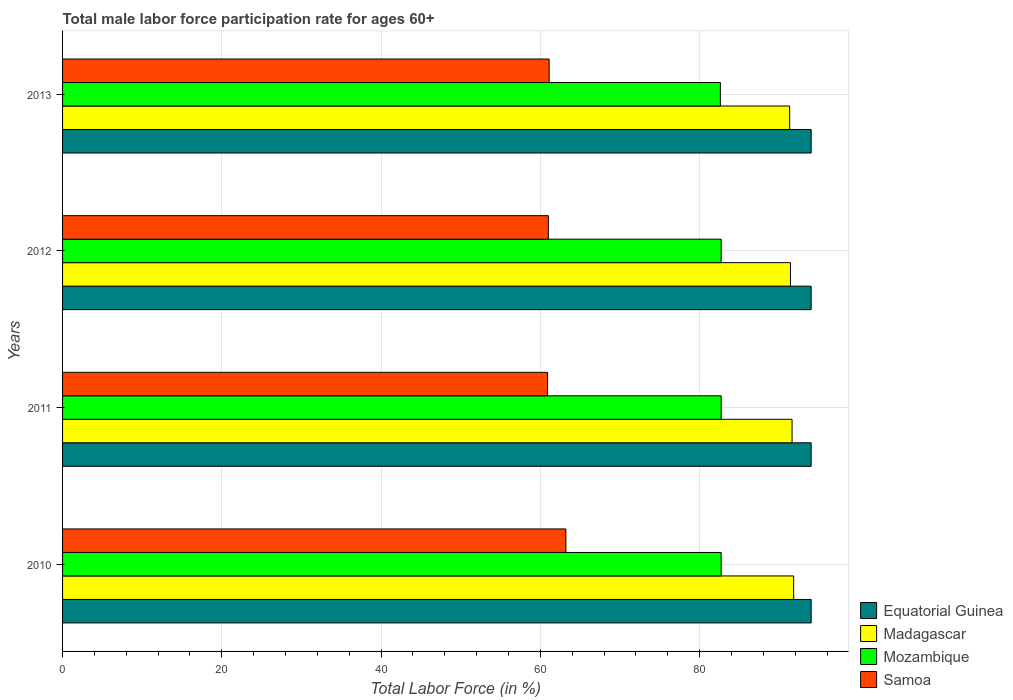How many groups of bars are there?
Make the answer very short. 4. Are the number of bars per tick equal to the number of legend labels?
Your response must be concise. Yes. Are the number of bars on each tick of the Y-axis equal?
Your response must be concise. Yes. How many bars are there on the 3rd tick from the top?
Provide a short and direct response. 4. How many bars are there on the 4th tick from the bottom?
Your response must be concise. 4. In how many cases, is the number of bars for a given year not equal to the number of legend labels?
Give a very brief answer. 0. What is the male labor force participation rate in Mozambique in 2013?
Offer a terse response. 82.6. Across all years, what is the maximum male labor force participation rate in Mozambique?
Offer a very short reply. 82.7. Across all years, what is the minimum male labor force participation rate in Madagascar?
Your response must be concise. 91.3. In which year was the male labor force participation rate in Mozambique maximum?
Offer a terse response. 2010. What is the total male labor force participation rate in Samoa in the graph?
Offer a very short reply. 246.2. What is the difference between the male labor force participation rate in Madagascar in 2011 and the male labor force participation rate in Samoa in 2013?
Your response must be concise. 30.5. What is the average male labor force participation rate in Madagascar per year?
Your answer should be very brief. 91.53. In the year 2013, what is the difference between the male labor force participation rate in Mozambique and male labor force participation rate in Equatorial Guinea?
Give a very brief answer. -11.4. What is the ratio of the male labor force participation rate in Mozambique in 2012 to that in 2013?
Provide a succinct answer. 1. What is the difference between the highest and the second highest male labor force participation rate in Mozambique?
Ensure brevity in your answer.  0. What is the difference between the highest and the lowest male labor force participation rate in Samoa?
Provide a short and direct response. 2.3. Is it the case that in every year, the sum of the male labor force participation rate in Equatorial Guinea and male labor force participation rate in Madagascar is greater than the sum of male labor force participation rate in Mozambique and male labor force participation rate in Samoa?
Provide a succinct answer. No. What does the 3rd bar from the top in 2013 represents?
Keep it short and to the point. Madagascar. What does the 2nd bar from the bottom in 2011 represents?
Provide a succinct answer. Madagascar. Is it the case that in every year, the sum of the male labor force participation rate in Madagascar and male labor force participation rate in Samoa is greater than the male labor force participation rate in Mozambique?
Offer a very short reply. Yes. How many bars are there?
Provide a succinct answer. 16. Are all the bars in the graph horizontal?
Ensure brevity in your answer.  Yes. How many years are there in the graph?
Make the answer very short. 4. Are the values on the major ticks of X-axis written in scientific E-notation?
Provide a succinct answer. No. Does the graph contain any zero values?
Provide a succinct answer. No. Where does the legend appear in the graph?
Make the answer very short. Bottom right. How are the legend labels stacked?
Provide a short and direct response. Vertical. What is the title of the graph?
Your response must be concise. Total male labor force participation rate for ages 60+. Does "High income: nonOECD" appear as one of the legend labels in the graph?
Your answer should be very brief. No. What is the label or title of the X-axis?
Keep it short and to the point. Total Labor Force (in %). What is the Total Labor Force (in %) in Equatorial Guinea in 2010?
Offer a terse response. 94. What is the Total Labor Force (in %) in Madagascar in 2010?
Make the answer very short. 91.8. What is the Total Labor Force (in %) in Mozambique in 2010?
Your answer should be compact. 82.7. What is the Total Labor Force (in %) of Samoa in 2010?
Offer a very short reply. 63.2. What is the Total Labor Force (in %) of Equatorial Guinea in 2011?
Your answer should be very brief. 94. What is the Total Labor Force (in %) of Madagascar in 2011?
Provide a short and direct response. 91.6. What is the Total Labor Force (in %) of Mozambique in 2011?
Give a very brief answer. 82.7. What is the Total Labor Force (in %) in Samoa in 2011?
Offer a terse response. 60.9. What is the Total Labor Force (in %) of Equatorial Guinea in 2012?
Provide a succinct answer. 94. What is the Total Labor Force (in %) in Madagascar in 2012?
Offer a very short reply. 91.4. What is the Total Labor Force (in %) of Mozambique in 2012?
Keep it short and to the point. 82.7. What is the Total Labor Force (in %) in Equatorial Guinea in 2013?
Give a very brief answer. 94. What is the Total Labor Force (in %) in Madagascar in 2013?
Your answer should be very brief. 91.3. What is the Total Labor Force (in %) in Mozambique in 2013?
Offer a very short reply. 82.6. What is the Total Labor Force (in %) in Samoa in 2013?
Provide a short and direct response. 61.1. Across all years, what is the maximum Total Labor Force (in %) in Equatorial Guinea?
Provide a succinct answer. 94. Across all years, what is the maximum Total Labor Force (in %) of Madagascar?
Your answer should be very brief. 91.8. Across all years, what is the maximum Total Labor Force (in %) of Mozambique?
Provide a short and direct response. 82.7. Across all years, what is the maximum Total Labor Force (in %) in Samoa?
Provide a short and direct response. 63.2. Across all years, what is the minimum Total Labor Force (in %) in Equatorial Guinea?
Your response must be concise. 94. Across all years, what is the minimum Total Labor Force (in %) in Madagascar?
Offer a very short reply. 91.3. Across all years, what is the minimum Total Labor Force (in %) of Mozambique?
Your response must be concise. 82.6. Across all years, what is the minimum Total Labor Force (in %) in Samoa?
Offer a terse response. 60.9. What is the total Total Labor Force (in %) in Equatorial Guinea in the graph?
Make the answer very short. 376. What is the total Total Labor Force (in %) of Madagascar in the graph?
Offer a terse response. 366.1. What is the total Total Labor Force (in %) of Mozambique in the graph?
Provide a short and direct response. 330.7. What is the total Total Labor Force (in %) of Samoa in the graph?
Provide a succinct answer. 246.2. What is the difference between the Total Labor Force (in %) in Equatorial Guinea in 2010 and that in 2011?
Provide a short and direct response. 0. What is the difference between the Total Labor Force (in %) in Madagascar in 2010 and that in 2011?
Your response must be concise. 0.2. What is the difference between the Total Labor Force (in %) in Mozambique in 2010 and that in 2011?
Your response must be concise. 0. What is the difference between the Total Labor Force (in %) of Samoa in 2010 and that in 2011?
Your answer should be compact. 2.3. What is the difference between the Total Labor Force (in %) of Equatorial Guinea in 2010 and that in 2012?
Your response must be concise. 0. What is the difference between the Total Labor Force (in %) in Mozambique in 2010 and that in 2012?
Make the answer very short. 0. What is the difference between the Total Labor Force (in %) in Samoa in 2010 and that in 2012?
Give a very brief answer. 2.2. What is the difference between the Total Labor Force (in %) of Madagascar in 2010 and that in 2013?
Offer a terse response. 0.5. What is the difference between the Total Labor Force (in %) in Samoa in 2010 and that in 2013?
Provide a succinct answer. 2.1. What is the difference between the Total Labor Force (in %) of Samoa in 2011 and that in 2012?
Your answer should be compact. -0.1. What is the difference between the Total Labor Force (in %) of Equatorial Guinea in 2011 and that in 2013?
Give a very brief answer. 0. What is the difference between the Total Labor Force (in %) in Mozambique in 2011 and that in 2013?
Give a very brief answer. 0.1. What is the difference between the Total Labor Force (in %) of Madagascar in 2012 and that in 2013?
Make the answer very short. 0.1. What is the difference between the Total Labor Force (in %) of Mozambique in 2012 and that in 2013?
Make the answer very short. 0.1. What is the difference between the Total Labor Force (in %) in Samoa in 2012 and that in 2013?
Your response must be concise. -0.1. What is the difference between the Total Labor Force (in %) of Equatorial Guinea in 2010 and the Total Labor Force (in %) of Madagascar in 2011?
Keep it short and to the point. 2.4. What is the difference between the Total Labor Force (in %) in Equatorial Guinea in 2010 and the Total Labor Force (in %) in Samoa in 2011?
Provide a succinct answer. 33.1. What is the difference between the Total Labor Force (in %) in Madagascar in 2010 and the Total Labor Force (in %) in Mozambique in 2011?
Ensure brevity in your answer.  9.1. What is the difference between the Total Labor Force (in %) of Madagascar in 2010 and the Total Labor Force (in %) of Samoa in 2011?
Give a very brief answer. 30.9. What is the difference between the Total Labor Force (in %) of Mozambique in 2010 and the Total Labor Force (in %) of Samoa in 2011?
Your answer should be compact. 21.8. What is the difference between the Total Labor Force (in %) of Equatorial Guinea in 2010 and the Total Labor Force (in %) of Mozambique in 2012?
Provide a short and direct response. 11.3. What is the difference between the Total Labor Force (in %) in Madagascar in 2010 and the Total Labor Force (in %) in Samoa in 2012?
Offer a terse response. 30.8. What is the difference between the Total Labor Force (in %) in Mozambique in 2010 and the Total Labor Force (in %) in Samoa in 2012?
Your response must be concise. 21.7. What is the difference between the Total Labor Force (in %) of Equatorial Guinea in 2010 and the Total Labor Force (in %) of Mozambique in 2013?
Provide a short and direct response. 11.4. What is the difference between the Total Labor Force (in %) of Equatorial Guinea in 2010 and the Total Labor Force (in %) of Samoa in 2013?
Give a very brief answer. 32.9. What is the difference between the Total Labor Force (in %) in Madagascar in 2010 and the Total Labor Force (in %) in Mozambique in 2013?
Your answer should be compact. 9.2. What is the difference between the Total Labor Force (in %) of Madagascar in 2010 and the Total Labor Force (in %) of Samoa in 2013?
Your answer should be compact. 30.7. What is the difference between the Total Labor Force (in %) in Mozambique in 2010 and the Total Labor Force (in %) in Samoa in 2013?
Offer a very short reply. 21.6. What is the difference between the Total Labor Force (in %) in Equatorial Guinea in 2011 and the Total Labor Force (in %) in Mozambique in 2012?
Your answer should be compact. 11.3. What is the difference between the Total Labor Force (in %) of Madagascar in 2011 and the Total Labor Force (in %) of Samoa in 2012?
Provide a short and direct response. 30.6. What is the difference between the Total Labor Force (in %) in Mozambique in 2011 and the Total Labor Force (in %) in Samoa in 2012?
Make the answer very short. 21.7. What is the difference between the Total Labor Force (in %) of Equatorial Guinea in 2011 and the Total Labor Force (in %) of Madagascar in 2013?
Ensure brevity in your answer.  2.7. What is the difference between the Total Labor Force (in %) in Equatorial Guinea in 2011 and the Total Labor Force (in %) in Mozambique in 2013?
Your answer should be very brief. 11.4. What is the difference between the Total Labor Force (in %) of Equatorial Guinea in 2011 and the Total Labor Force (in %) of Samoa in 2013?
Your response must be concise. 32.9. What is the difference between the Total Labor Force (in %) in Madagascar in 2011 and the Total Labor Force (in %) in Mozambique in 2013?
Provide a short and direct response. 9. What is the difference between the Total Labor Force (in %) of Madagascar in 2011 and the Total Labor Force (in %) of Samoa in 2013?
Offer a terse response. 30.5. What is the difference between the Total Labor Force (in %) in Mozambique in 2011 and the Total Labor Force (in %) in Samoa in 2013?
Your answer should be very brief. 21.6. What is the difference between the Total Labor Force (in %) in Equatorial Guinea in 2012 and the Total Labor Force (in %) in Madagascar in 2013?
Give a very brief answer. 2.7. What is the difference between the Total Labor Force (in %) of Equatorial Guinea in 2012 and the Total Labor Force (in %) of Samoa in 2013?
Keep it short and to the point. 32.9. What is the difference between the Total Labor Force (in %) of Madagascar in 2012 and the Total Labor Force (in %) of Samoa in 2013?
Your response must be concise. 30.3. What is the difference between the Total Labor Force (in %) in Mozambique in 2012 and the Total Labor Force (in %) in Samoa in 2013?
Your answer should be very brief. 21.6. What is the average Total Labor Force (in %) of Equatorial Guinea per year?
Your answer should be compact. 94. What is the average Total Labor Force (in %) in Madagascar per year?
Provide a succinct answer. 91.53. What is the average Total Labor Force (in %) of Mozambique per year?
Ensure brevity in your answer.  82.67. What is the average Total Labor Force (in %) of Samoa per year?
Give a very brief answer. 61.55. In the year 2010, what is the difference between the Total Labor Force (in %) of Equatorial Guinea and Total Labor Force (in %) of Madagascar?
Your answer should be compact. 2.2. In the year 2010, what is the difference between the Total Labor Force (in %) in Equatorial Guinea and Total Labor Force (in %) in Mozambique?
Make the answer very short. 11.3. In the year 2010, what is the difference between the Total Labor Force (in %) of Equatorial Guinea and Total Labor Force (in %) of Samoa?
Keep it short and to the point. 30.8. In the year 2010, what is the difference between the Total Labor Force (in %) of Madagascar and Total Labor Force (in %) of Samoa?
Provide a succinct answer. 28.6. In the year 2010, what is the difference between the Total Labor Force (in %) in Mozambique and Total Labor Force (in %) in Samoa?
Your answer should be compact. 19.5. In the year 2011, what is the difference between the Total Labor Force (in %) in Equatorial Guinea and Total Labor Force (in %) in Samoa?
Ensure brevity in your answer.  33.1. In the year 2011, what is the difference between the Total Labor Force (in %) of Madagascar and Total Labor Force (in %) of Mozambique?
Give a very brief answer. 8.9. In the year 2011, what is the difference between the Total Labor Force (in %) in Madagascar and Total Labor Force (in %) in Samoa?
Make the answer very short. 30.7. In the year 2011, what is the difference between the Total Labor Force (in %) in Mozambique and Total Labor Force (in %) in Samoa?
Keep it short and to the point. 21.8. In the year 2012, what is the difference between the Total Labor Force (in %) of Equatorial Guinea and Total Labor Force (in %) of Madagascar?
Keep it short and to the point. 2.6. In the year 2012, what is the difference between the Total Labor Force (in %) in Equatorial Guinea and Total Labor Force (in %) in Mozambique?
Your answer should be compact. 11.3. In the year 2012, what is the difference between the Total Labor Force (in %) in Madagascar and Total Labor Force (in %) in Samoa?
Your response must be concise. 30.4. In the year 2012, what is the difference between the Total Labor Force (in %) of Mozambique and Total Labor Force (in %) of Samoa?
Your response must be concise. 21.7. In the year 2013, what is the difference between the Total Labor Force (in %) of Equatorial Guinea and Total Labor Force (in %) of Mozambique?
Your response must be concise. 11.4. In the year 2013, what is the difference between the Total Labor Force (in %) of Equatorial Guinea and Total Labor Force (in %) of Samoa?
Offer a very short reply. 32.9. In the year 2013, what is the difference between the Total Labor Force (in %) in Madagascar and Total Labor Force (in %) in Samoa?
Your response must be concise. 30.2. In the year 2013, what is the difference between the Total Labor Force (in %) in Mozambique and Total Labor Force (in %) in Samoa?
Keep it short and to the point. 21.5. What is the ratio of the Total Labor Force (in %) in Samoa in 2010 to that in 2011?
Ensure brevity in your answer.  1.04. What is the ratio of the Total Labor Force (in %) of Mozambique in 2010 to that in 2012?
Your answer should be compact. 1. What is the ratio of the Total Labor Force (in %) of Samoa in 2010 to that in 2012?
Keep it short and to the point. 1.04. What is the ratio of the Total Labor Force (in %) in Equatorial Guinea in 2010 to that in 2013?
Provide a succinct answer. 1. What is the ratio of the Total Labor Force (in %) in Mozambique in 2010 to that in 2013?
Keep it short and to the point. 1. What is the ratio of the Total Labor Force (in %) in Samoa in 2010 to that in 2013?
Offer a very short reply. 1.03. What is the ratio of the Total Labor Force (in %) of Madagascar in 2011 to that in 2012?
Your answer should be very brief. 1. What is the ratio of the Total Labor Force (in %) in Mozambique in 2011 to that in 2012?
Ensure brevity in your answer.  1. What is the ratio of the Total Labor Force (in %) of Samoa in 2011 to that in 2012?
Keep it short and to the point. 1. What is the ratio of the Total Labor Force (in %) in Equatorial Guinea in 2011 to that in 2013?
Your response must be concise. 1. What is the ratio of the Total Labor Force (in %) of Samoa in 2012 to that in 2013?
Provide a succinct answer. 1. What is the difference between the highest and the second highest Total Labor Force (in %) in Equatorial Guinea?
Your answer should be very brief. 0. What is the difference between the highest and the second highest Total Labor Force (in %) in Madagascar?
Offer a very short reply. 0.2. What is the difference between the highest and the second highest Total Labor Force (in %) in Mozambique?
Your response must be concise. 0. What is the difference between the highest and the lowest Total Labor Force (in %) of Equatorial Guinea?
Ensure brevity in your answer.  0. What is the difference between the highest and the lowest Total Labor Force (in %) in Madagascar?
Offer a terse response. 0.5. What is the difference between the highest and the lowest Total Labor Force (in %) in Mozambique?
Provide a short and direct response. 0.1. 